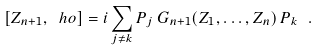Convert formula to latex. <formula><loc_0><loc_0><loc_500><loc_500>\left [ Z _ { n + 1 } , \ h o \right ] = i \sum _ { j \neq k } P _ { j } \, G _ { n + 1 } ( Z _ { 1 } , \dots , Z _ { n } ) \, P _ { k } \ .</formula> 